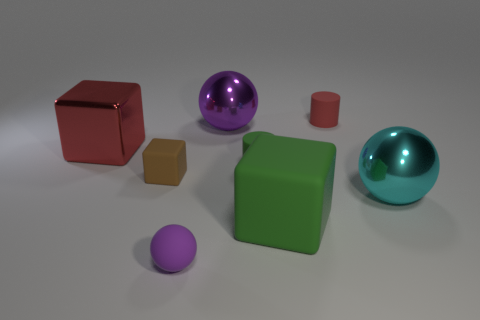Is the number of green cylinders less than the number of large yellow metal cylinders? Yes, there are fewer green cylinders compared to large yellow metal cylinders. The image shows only one green cylinder, while there are no large yellow metal cylinders visible at all, making the question not applicable as there are zero yellow metal cylinders to compare with. 